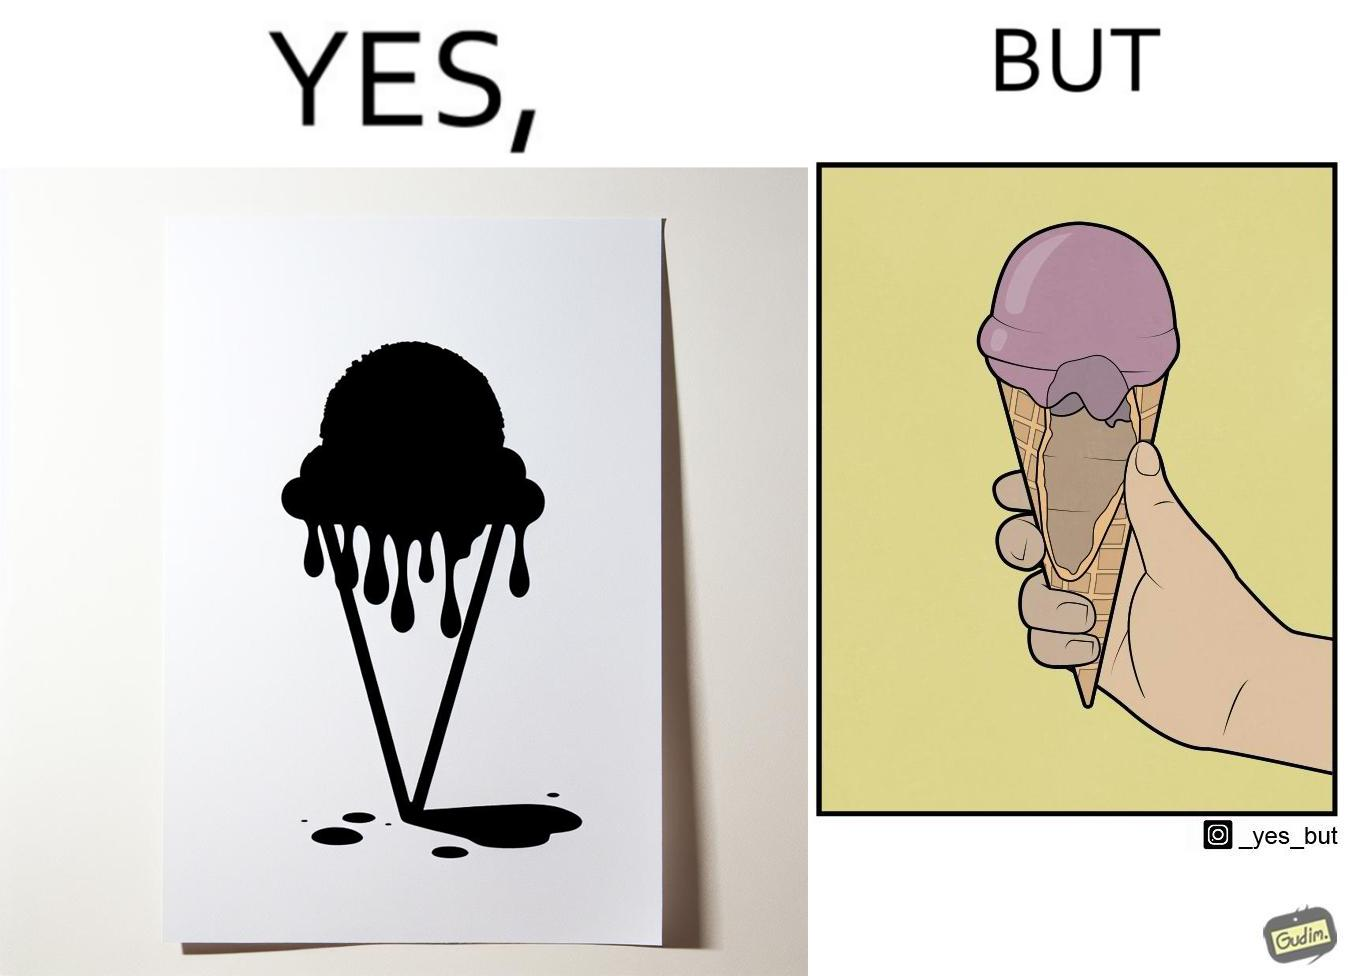What is shown in the left half versus the right half of this image? In the left part of the image: a softy cone filed with ice cream at top and probably melting from the sides because of more quantity than space In the right part of the image: an open section of softy cone showing only a limited softy is filled over the cone and the hollow part of ice cream is empty or vacant 